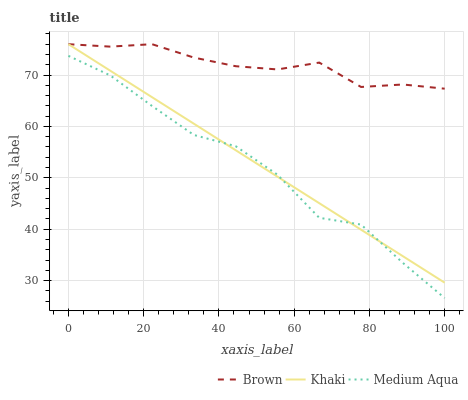Does Medium Aqua have the minimum area under the curve?
Answer yes or no. Yes. Does Brown have the maximum area under the curve?
Answer yes or no. Yes. Does Khaki have the minimum area under the curve?
Answer yes or no. No. Does Khaki have the maximum area under the curve?
Answer yes or no. No. Is Khaki the smoothest?
Answer yes or no. Yes. Is Medium Aqua the roughest?
Answer yes or no. Yes. Is Medium Aqua the smoothest?
Answer yes or no. No. Is Khaki the roughest?
Answer yes or no. No. Does Medium Aqua have the lowest value?
Answer yes or no. Yes. Does Khaki have the lowest value?
Answer yes or no. No. Does Khaki have the highest value?
Answer yes or no. Yes. Does Medium Aqua have the highest value?
Answer yes or no. No. Is Medium Aqua less than Brown?
Answer yes or no. Yes. Is Brown greater than Medium Aqua?
Answer yes or no. Yes. Does Khaki intersect Brown?
Answer yes or no. Yes. Is Khaki less than Brown?
Answer yes or no. No. Is Khaki greater than Brown?
Answer yes or no. No. Does Medium Aqua intersect Brown?
Answer yes or no. No. 